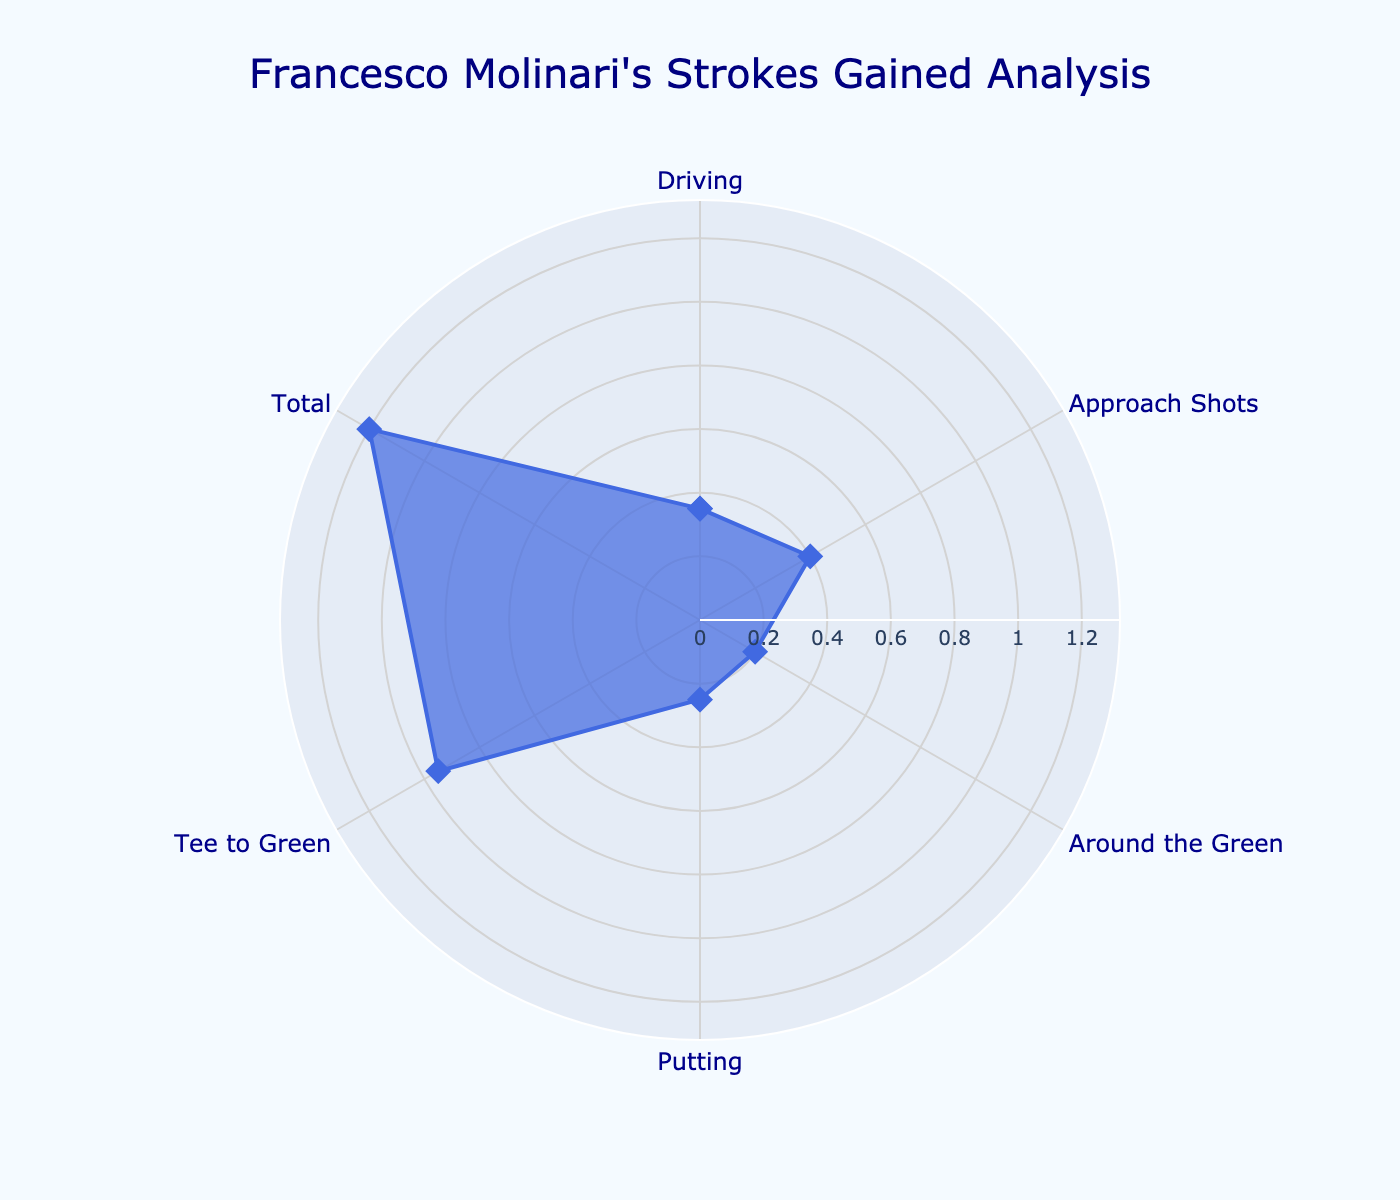What's the title of the figure? The title of the figure is displayed prominently at the top and reads "Francesco Molinari's Strokes Gained Analysis."
Answer: Francesco Molinari's Strokes Gained Analysis How many categories of strokes gained are analyzed? The figure has labeled points on the polar plot denoting different categories, and counting these labels gives the total number.
Answer: 6 Which category shows the highest strokes gained? By comparing the radial distances of the points, the category with the largest distance from the center represents the highest strokes gained.
Answer: Total What's the strokes gained for the "Putting" category? The label corresponding to "Putting" on the plot shows the strokes gained directly next to the point.
Answer: 0.25 Is Molinari's strokes gained for "Driving" higher or lower than that for "Putting"? By comparing the radial points for "Driving" and "Putting," we can see if "Driving" has a greater or smaller distance from the center.
Answer: Higher Which categories have strokes gained less than 0.30? We need to examine each category's strokes gained and identify those with values under 0.30. "Driving" (0.35) and "Putting" (0.25) should be considered.
Answer: Putting, Around the Green Are the categories "Driving" and "Approach Shots" closer to each other compared to "Approach Shots" and "Putting"? Measure the radial distances for "Driving" (0.35) and "Approach Shots" (0.40), then for "Approach Shots" and "Putting" (0.25), and compare the absolute differences.
Answer: Yes What is the total strokes gained by Molinari for all categories combined? Sum up the strokes gained values for all the categories: 0.35 (Driving) + 0.40 (Approach Shots) + 0.20 (Around the Green) + 0.25 (Putting) + 0.95 (Tee to Green) + 1.20 (Total).
Answer: 3.35 